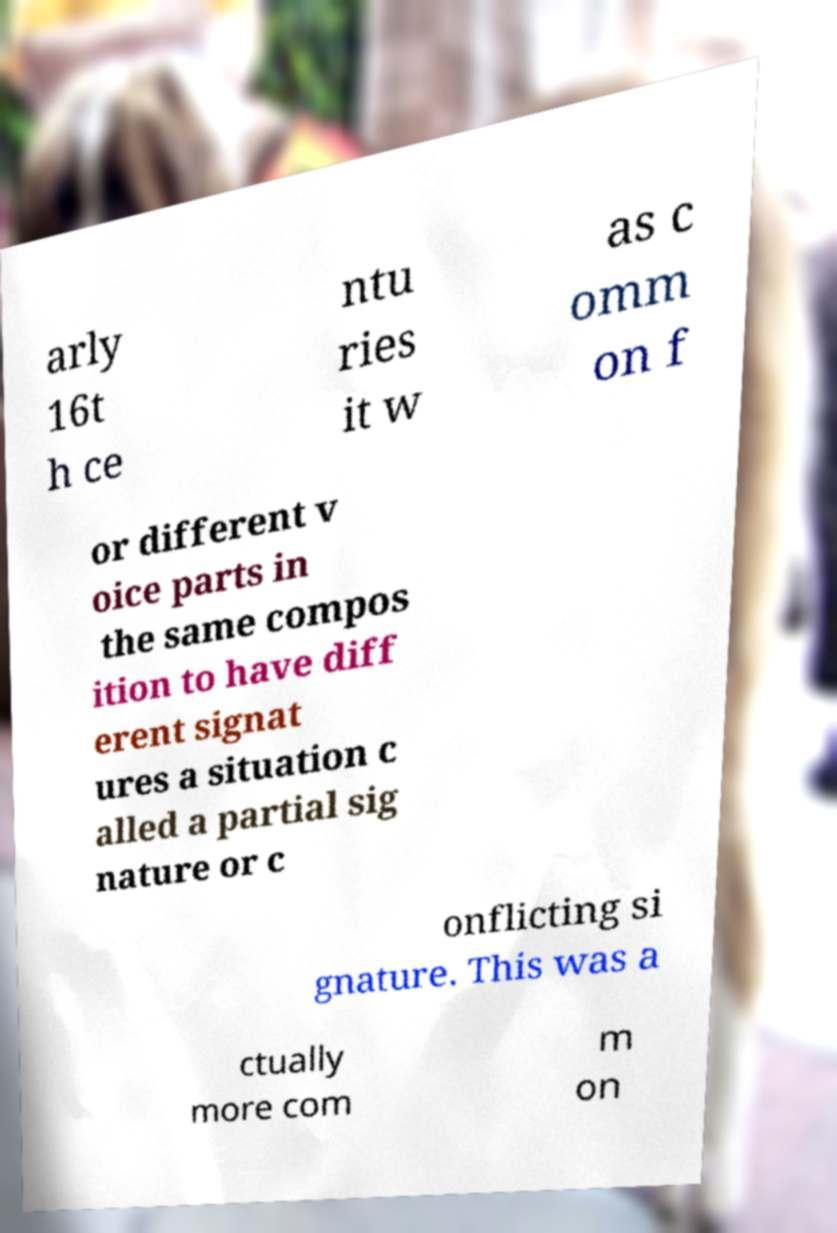I need the written content from this picture converted into text. Can you do that? arly 16t h ce ntu ries it w as c omm on f or different v oice parts in the same compos ition to have diff erent signat ures a situation c alled a partial sig nature or c onflicting si gnature. This was a ctually more com m on 